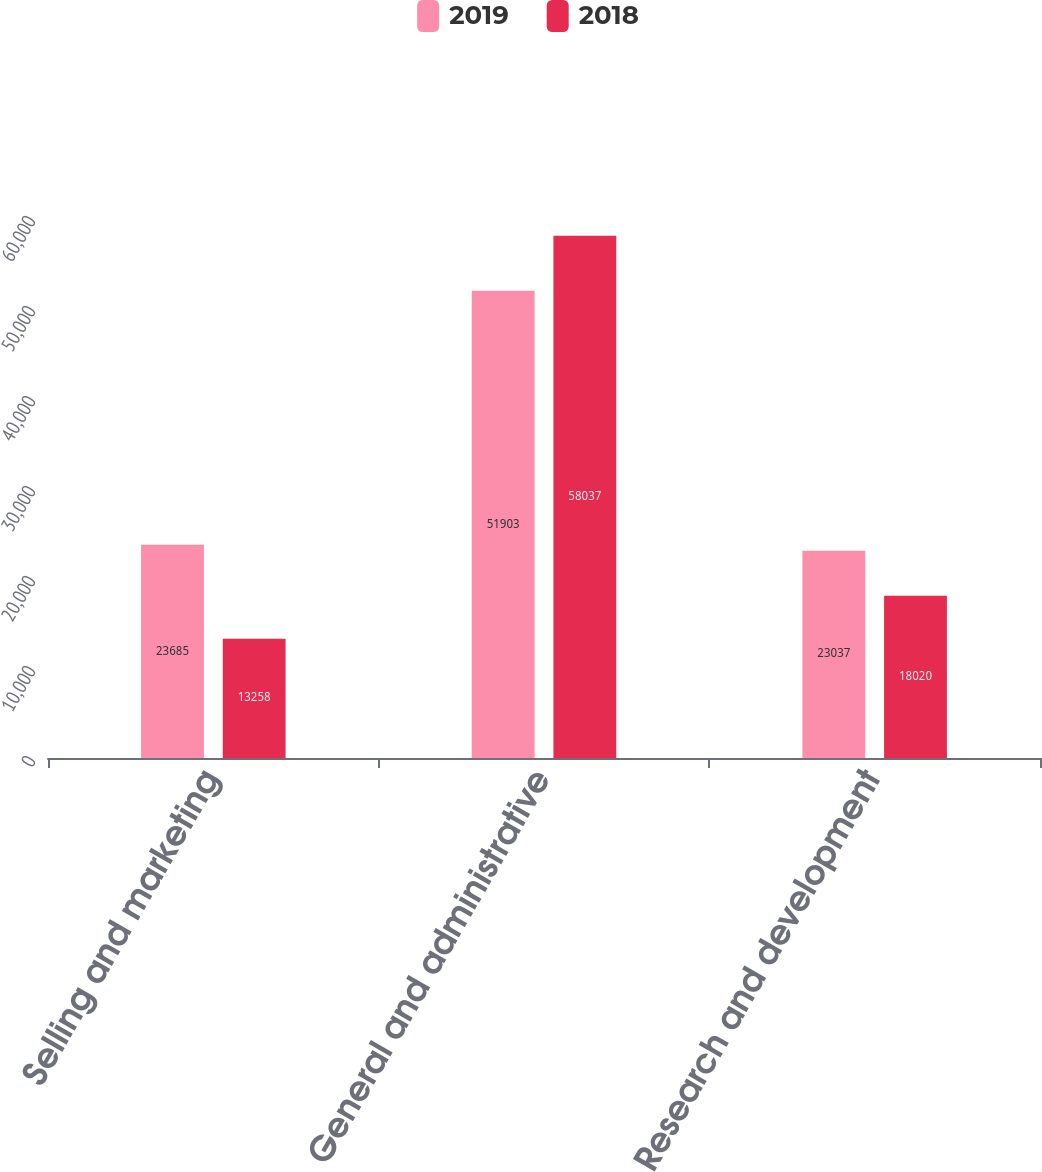Convert chart to OTSL. <chart><loc_0><loc_0><loc_500><loc_500><stacked_bar_chart><ecel><fcel>Selling and marketing<fcel>General and administrative<fcel>Research and development<nl><fcel>2019<fcel>23685<fcel>51903<fcel>23037<nl><fcel>2018<fcel>13258<fcel>58037<fcel>18020<nl></chart> 